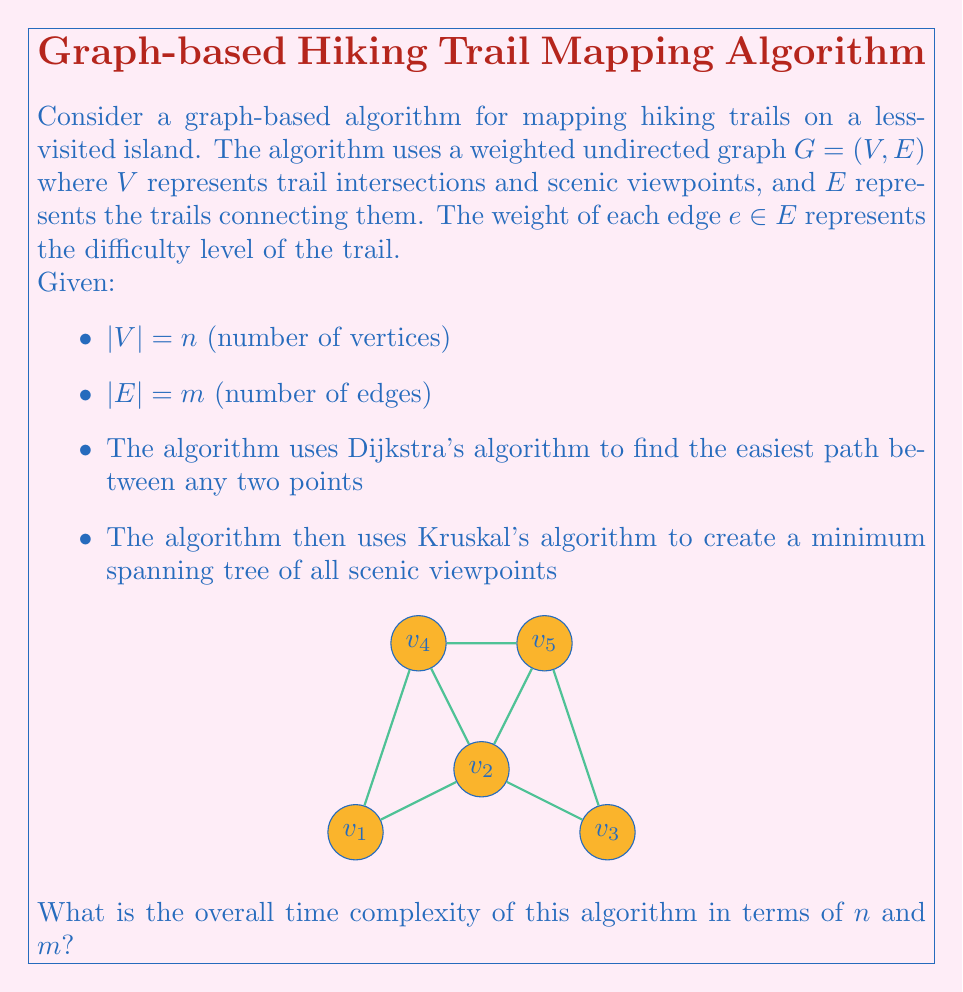What is the answer to this math problem? To determine the overall time complexity, we need to analyze each component of the algorithm:

1. Dijkstra's Algorithm:
   - Using a binary heap implementation, Dijkstra's algorithm has a time complexity of $O((m + n) \log n)$ for a single source.
   - If we need to find the easiest path between all pairs of points, we would run Dijkstra's algorithm $n$ times.
   - This gives us a total complexity of $O(n(m + n) \log n)$ for this step.

2. Kruskal's Algorithm:
   - Sorting the edges takes $O(m \log m)$ time.
   - The union-find operations take $O(m \alpha(n))$ time, where $\alpha(n)$ is the inverse Ackermann function.
   - The total complexity for Kruskal's algorithm is $O(m \log m)$.

3. Overall Complexity:
   - The total complexity is the sum of the complexities of both algorithms.
   - $O(n(m + n) \log n + m \log m)$

4. Simplification:
   - Since $m$ can be at most $n(n-1)/2$ for a simple graph, $\log m = O(\log n)$.
   - Therefore, $m \log m = O(m \log n)$.
   - The term $n(m + n) \log n$ dominates $m \log n$.

Thus, the overall time complexity simplifies to $O(n(m + n) \log n)$.
Answer: $O(n(m + n) \log n)$ 